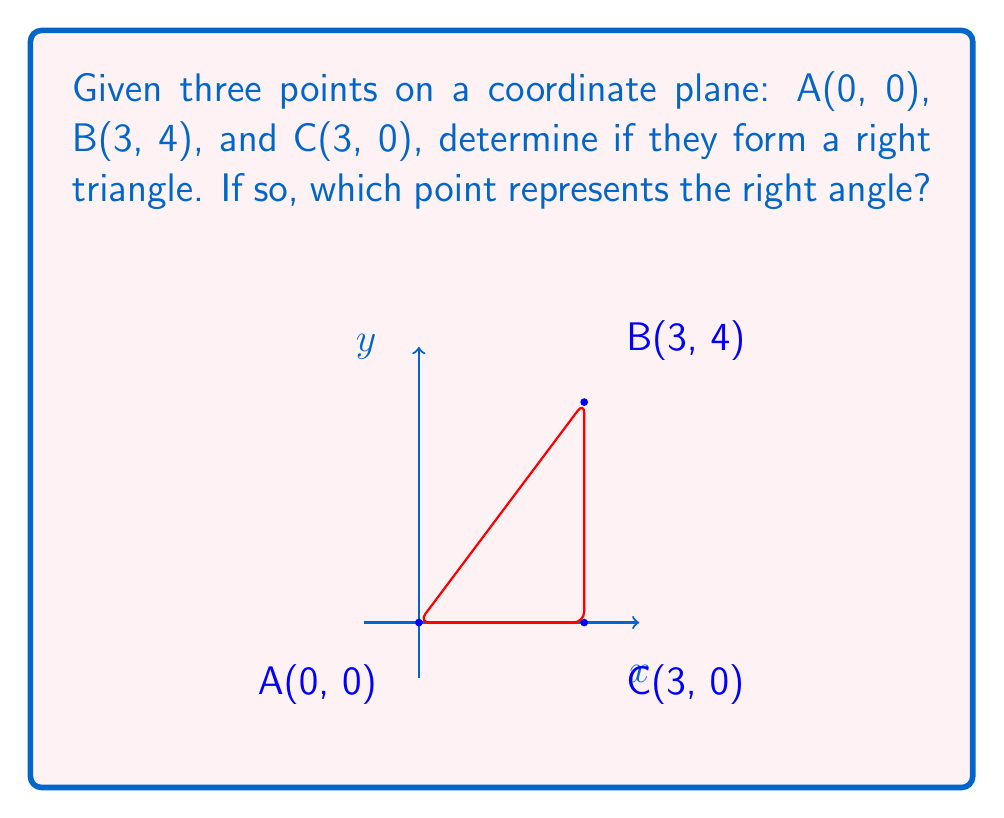Show me your answer to this math problem. To determine if three points form a right triangle, we can use the Pythagorean theorem. If the sum of the squares of the lengths of two sides equals the square of the length of the third side, then the triangle is a right triangle.

Step 1: Calculate the lengths of all sides using the distance formula:
$d = \sqrt{(x_2-x_1)^2 + (y_2-y_1)^2}$

AB: $\sqrt{(3-0)^2 + (4-0)^2} = \sqrt{9 + 16} = \sqrt{25} = 5$
BC: $\sqrt{(3-3)^2 + (0-4)^2} = \sqrt{0 + 16} = 4$
AC: $\sqrt{(3-0)^2 + (0-0)^2} = \sqrt{9 + 0} = 3$

Step 2: Check if the Pythagorean theorem holds for any combination of sides:

$$AB^2 = BC^2 + AC^2$$
$$5^2 = 4^2 + 3^2$$
$$25 = 16 + 9$$
$$25 = 25$$

Since the equation holds true, these points do form a right triangle.

Step 3: Identify the right angle:
The right angle is at point C(3, 0), as it's the vertex where the two shorter sides (BC and AC) meet.
Answer: Yes; C(3, 0) 